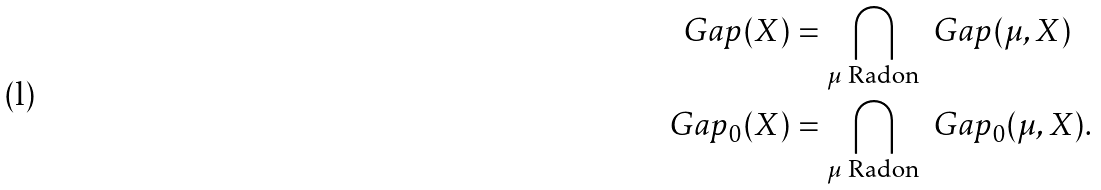<formula> <loc_0><loc_0><loc_500><loc_500>\ G a p ( X ) & = \bigcap _ { \text {$\mu$ Radon} } \ G a p ( \mu , X ) \\ \ G a p _ { 0 } ( X ) & = \bigcap _ { \text {$\mu$ Radon} } \ G a p _ { 0 } ( \mu , X ) .</formula> 